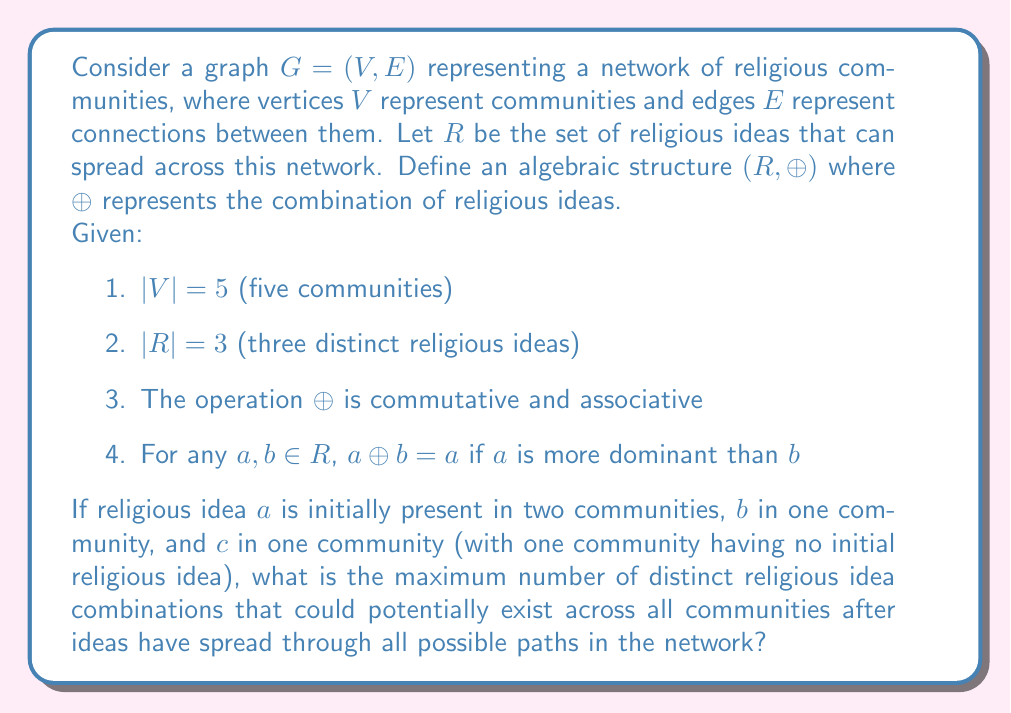Show me your answer to this math problem. To solve this problem, we need to consider the possible combinations of religious ideas that can form as they spread through the network. Let's approach this step-by-step:

1) First, we need to understand the algebraic structure $(R, \oplus)$:
   - $R = \{a, b, c\}$
   - $\oplus$ is commutative and associative
   - $a \oplus b = a$ if $a$ is more dominant than $b$

2) Given the dominance property, we can assume without loss of generality that $a$ is more dominant than $b$, which is more dominant than $c$. This gives us:
   
   $a \oplus b = a$
   $a \oplus c = a$
   $b \oplus c = b$

3) Now, let's list all possible combinations of religious ideas:
   
   - Single ideas: $a$, $b$, $c$
   - Two-idea combinations: $a \oplus b = a$, $a \oplus c = a$, $b \oplus c = b$
   - Three-idea combination: $a \oplus b \oplus c = a$

4) From this, we can see that there are only 4 distinct outcomes: $a$, $b$, $c$, and the absence of any idea (which we can denote as $\emptyset$).

5) The initial state of the communities is:
   - Two communities with $a$
   - One community with $b$
   - One community with $c$
   - One community with no idea ($\emptyset$)

6) As ideas spread through the network, each community could potentially end up with any of these 4 distinct outcomes ($a$, $b$, $c$, or $\emptyset$).

7) The maximum number of distinct combinations across all communities would occur if each community ended up with a different outcome. Since there are 5 communities and only 4 distinct outcomes, the maximum number of distinct combinations is 4.
Answer: The maximum number of distinct religious idea combinations that could potentially exist across all communities after ideas have spread is 4. 